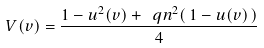<formula> <loc_0><loc_0><loc_500><loc_500>V ( v ) = \frac { 1 - u ^ { 2 } ( v ) + \ q n ^ { 2 } ( \, 1 - u ( v ) \, ) } { 4 }</formula> 